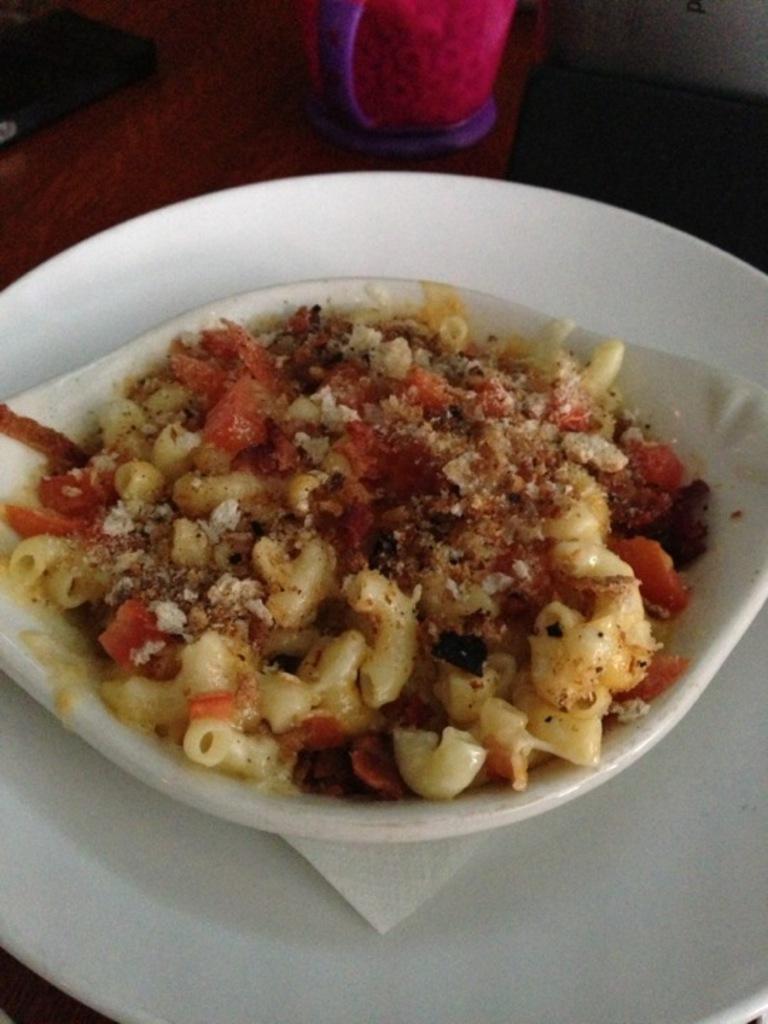Could you give a brief overview of what you see in this image? In this image we can see a food items in a bowl. At the bottom of the image there is white color plate on the table. There is a cup. 